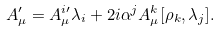<formula> <loc_0><loc_0><loc_500><loc_500>A _ { \mu } ^ { \prime } = A ^ { i \prime } _ { \mu } \lambda _ { i } + 2 i \alpha ^ { j } A ^ { k } _ { \mu } [ \rho _ { k } , \lambda _ { j } ] .</formula> 